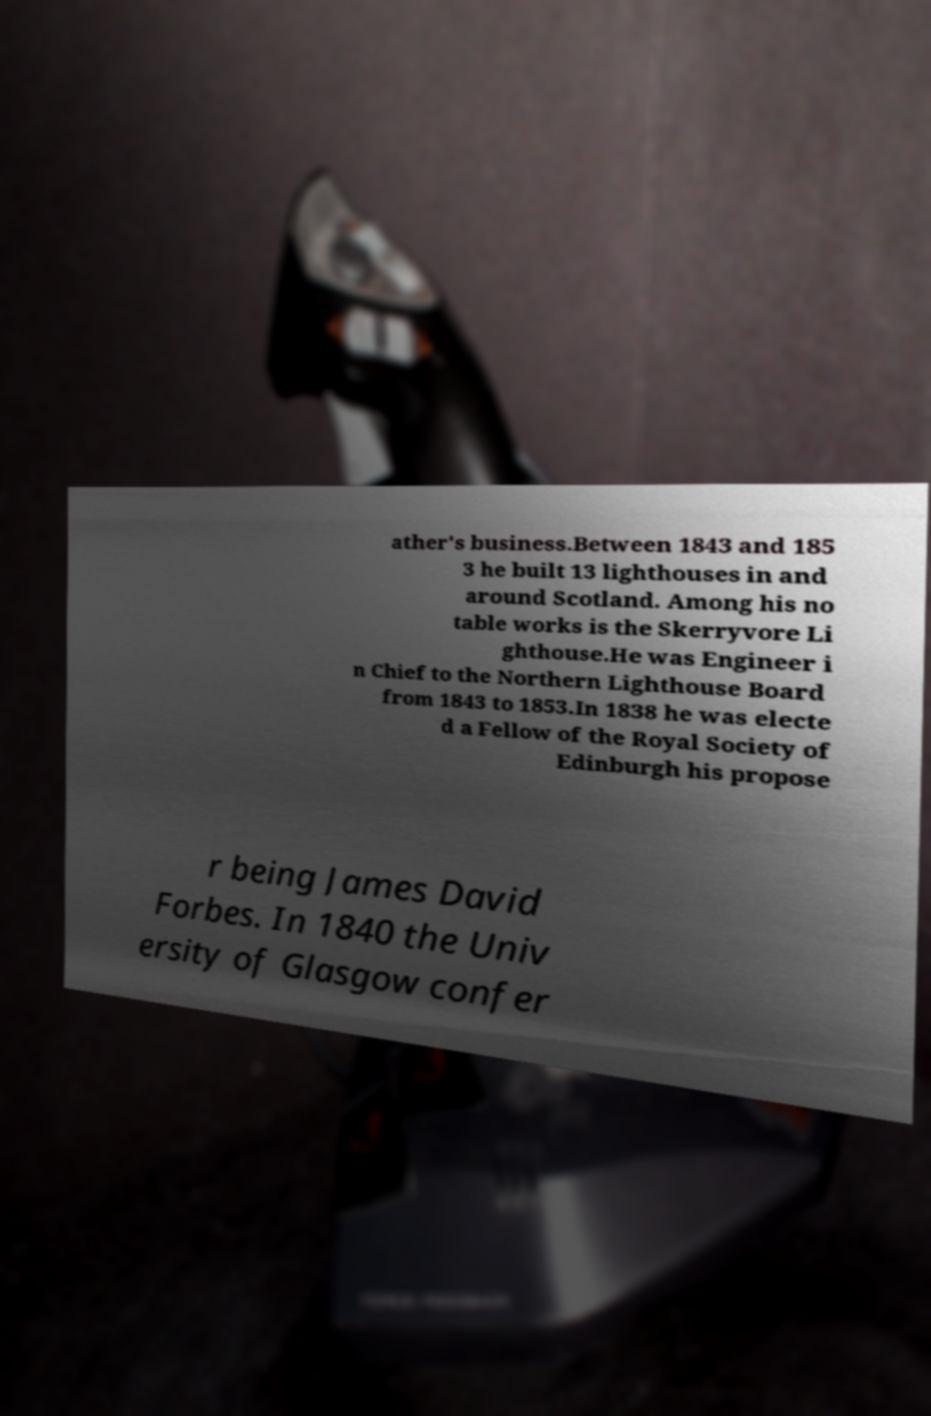Please read and relay the text visible in this image. What does it say? ather's business.Between 1843 and 185 3 he built 13 lighthouses in and around Scotland. Among his no table works is the Skerryvore Li ghthouse.He was Engineer i n Chief to the Northern Lighthouse Board from 1843 to 1853.In 1838 he was electe d a Fellow of the Royal Society of Edinburgh his propose r being James David Forbes. In 1840 the Univ ersity of Glasgow confer 